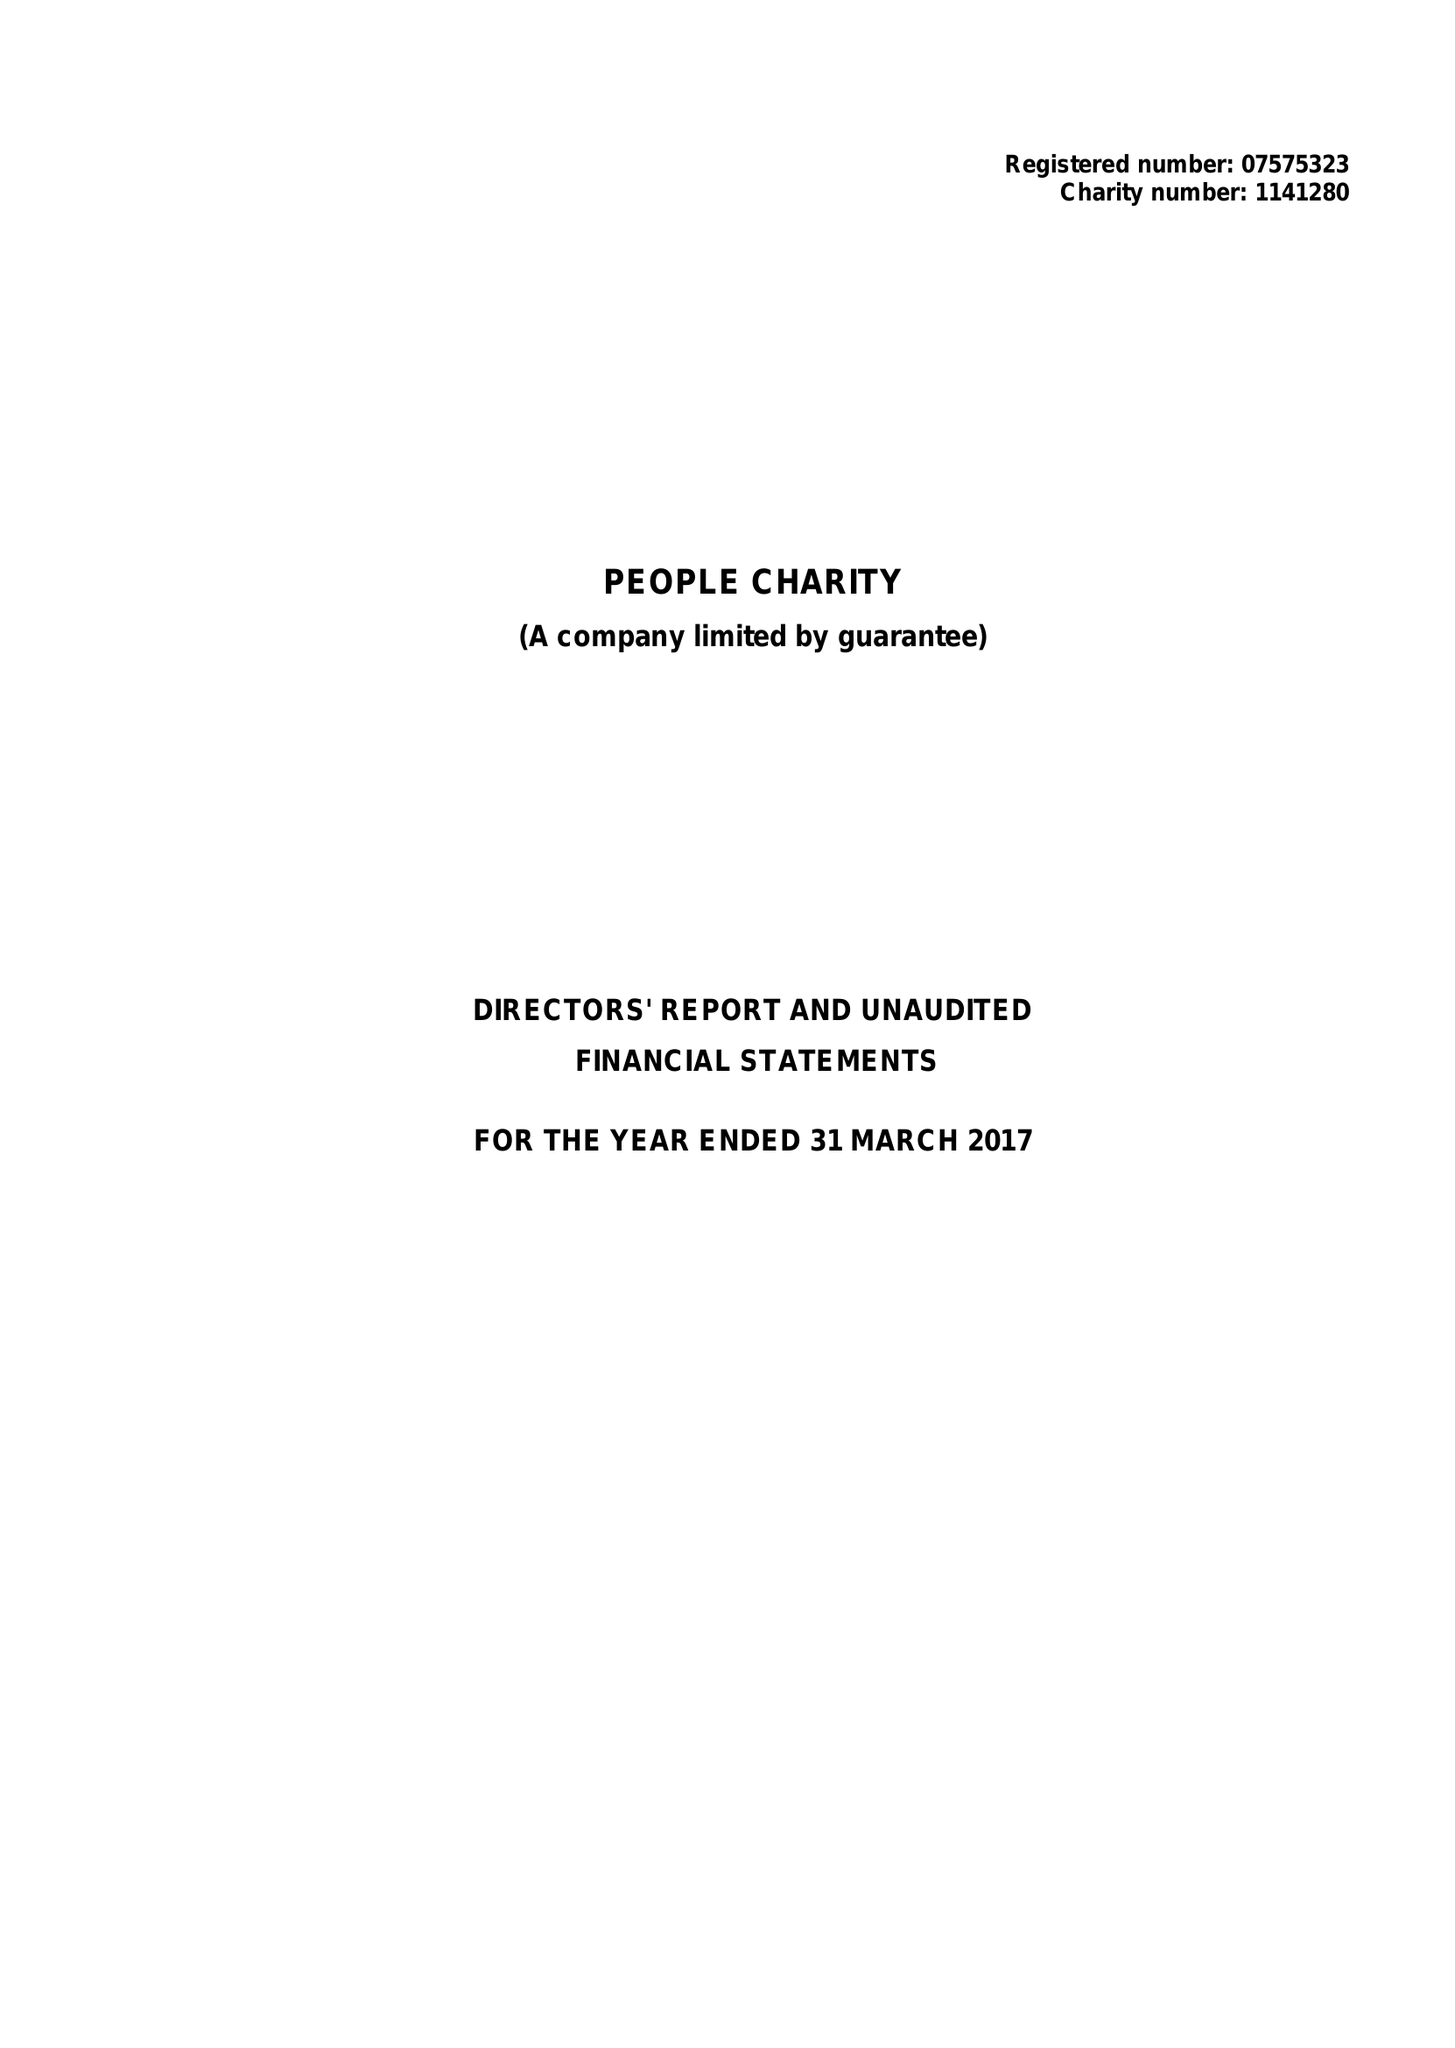What is the value for the address__street_line?
Answer the question using a single word or phrase. 50 WESTMINSTER BRIDGE ROAD 